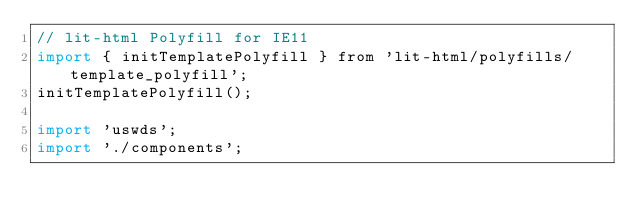Convert code to text. <code><loc_0><loc_0><loc_500><loc_500><_JavaScript_>// lit-html Polyfill for IE11
import { initTemplatePolyfill } from 'lit-html/polyfills/template_polyfill';
initTemplatePolyfill();

import 'uswds';
import './components';
</code> 